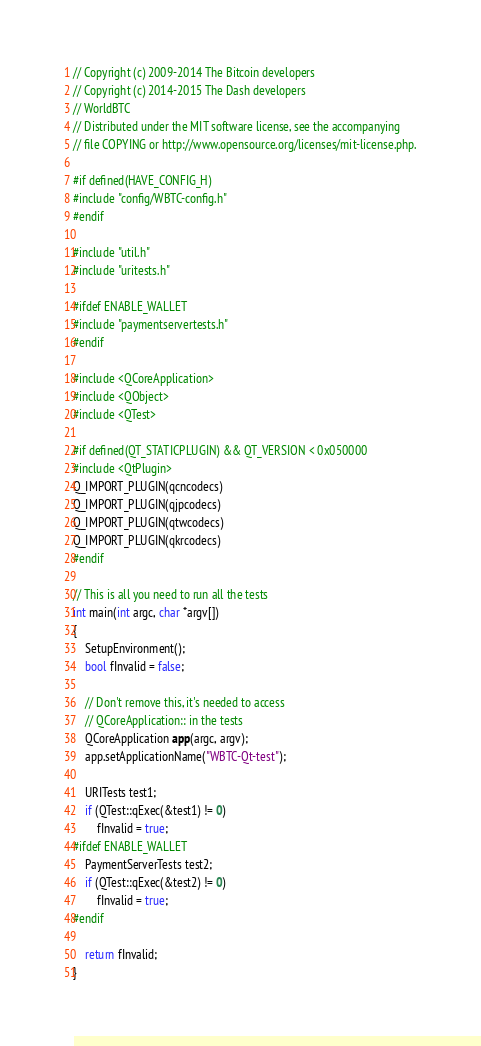Convert code to text. <code><loc_0><loc_0><loc_500><loc_500><_C++_>// Copyright (c) 2009-2014 The Bitcoin developers
// Copyright (c) 2014-2015 The Dash developers
// WorldBTC
// Distributed under the MIT software license, see the accompanying
// file COPYING or http://www.opensource.org/licenses/mit-license.php.

#if defined(HAVE_CONFIG_H)
#include "config/WBTC-config.h"
#endif

#include "util.h"
#include "uritests.h"

#ifdef ENABLE_WALLET
#include "paymentservertests.h"
#endif

#include <QCoreApplication>
#include <QObject>
#include <QTest>

#if defined(QT_STATICPLUGIN) && QT_VERSION < 0x050000
#include <QtPlugin>
Q_IMPORT_PLUGIN(qcncodecs)
Q_IMPORT_PLUGIN(qjpcodecs)
Q_IMPORT_PLUGIN(qtwcodecs)
Q_IMPORT_PLUGIN(qkrcodecs)
#endif

// This is all you need to run all the tests
int main(int argc, char *argv[])
{
    SetupEnvironment();
    bool fInvalid = false;

    // Don't remove this, it's needed to access
    // QCoreApplication:: in the tests
    QCoreApplication app(argc, argv);
    app.setApplicationName("WBTC-Qt-test");

    URITests test1;
    if (QTest::qExec(&test1) != 0)
        fInvalid = true;
#ifdef ENABLE_WALLET
    PaymentServerTests test2;
    if (QTest::qExec(&test2) != 0)
        fInvalid = true;
#endif

    return fInvalid;
}
</code> 